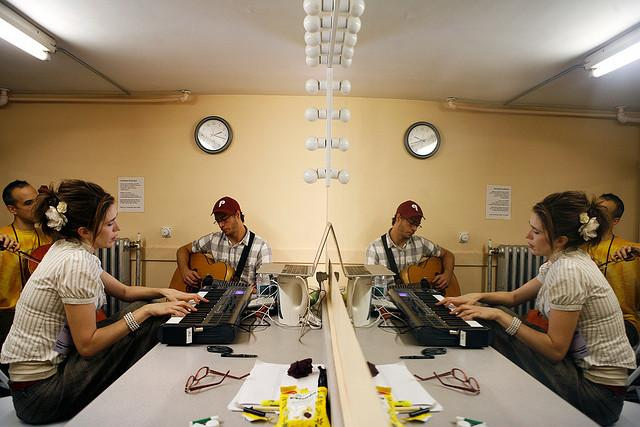At least how many musicians play different instruments here? Please explain your reasoning. three. The mirror makes it look like there are more 